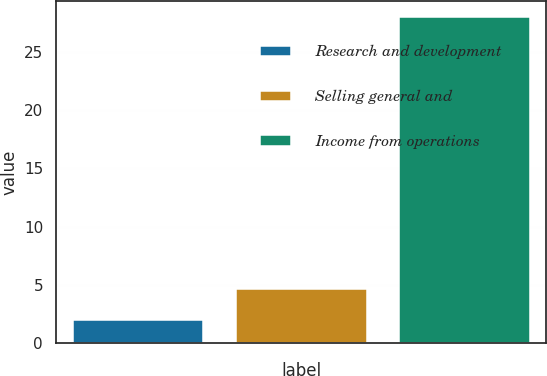Convert chart. <chart><loc_0><loc_0><loc_500><loc_500><bar_chart><fcel>Research and development<fcel>Selling general and<fcel>Income from operations<nl><fcel>2<fcel>4.6<fcel>28<nl></chart> 